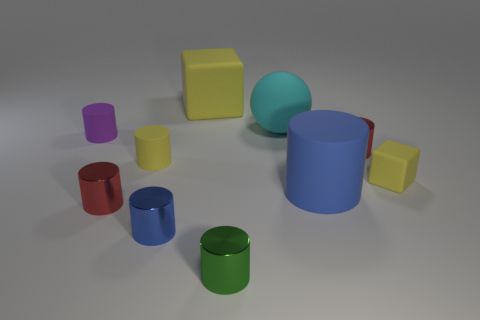Subtract 2 cylinders. How many cylinders are left? 5 Subtract all yellow cylinders. How many cylinders are left? 6 Subtract all small yellow rubber cylinders. How many cylinders are left? 6 Subtract all blue cylinders. Subtract all brown spheres. How many cylinders are left? 5 Subtract all spheres. How many objects are left? 9 Subtract 0 gray cubes. How many objects are left? 10 Subtract all large red metal blocks. Subtract all yellow rubber objects. How many objects are left? 7 Add 8 blue rubber objects. How many blue rubber objects are left? 9 Add 3 yellow matte things. How many yellow matte things exist? 6 